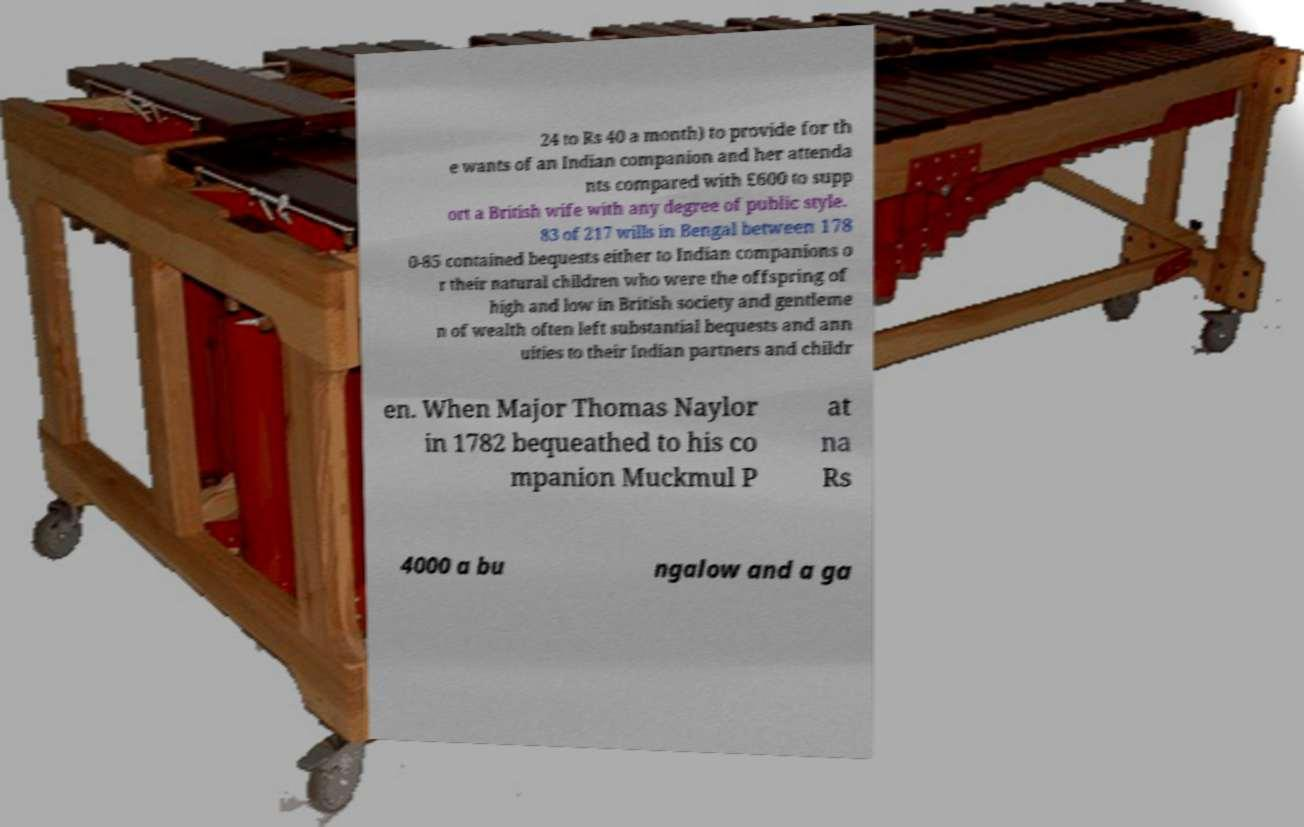What messages or text are displayed in this image? I need them in a readable, typed format. 24 to Rs 40 a month) to provide for th e wants of an Indian companion and her attenda nts compared with £600 to supp ort a British wife with any degree of public style. 83 of 217 wills in Bengal between 178 0-85 contained bequests either to Indian companions o r their natural children who were the offspring of high and low in British society and gentleme n of wealth often left substantial bequests and ann uities to their Indian partners and childr en. When Major Thomas Naylor in 1782 bequeathed to his co mpanion Muckmul P at na Rs 4000 a bu ngalow and a ga 